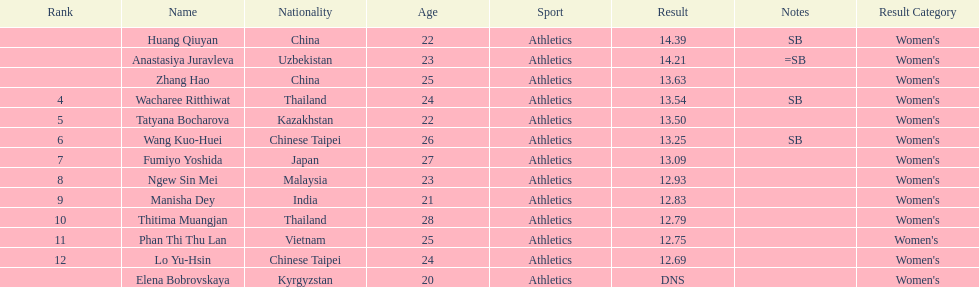How many people were ranked? 12. 